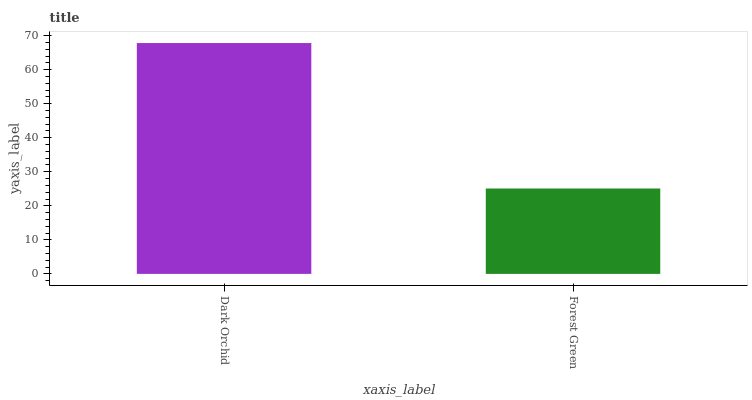Is Forest Green the minimum?
Answer yes or no. Yes. Is Dark Orchid the maximum?
Answer yes or no. Yes. Is Forest Green the maximum?
Answer yes or no. No. Is Dark Orchid greater than Forest Green?
Answer yes or no. Yes. Is Forest Green less than Dark Orchid?
Answer yes or no. Yes. Is Forest Green greater than Dark Orchid?
Answer yes or no. No. Is Dark Orchid less than Forest Green?
Answer yes or no. No. Is Dark Orchid the high median?
Answer yes or no. Yes. Is Forest Green the low median?
Answer yes or no. Yes. Is Forest Green the high median?
Answer yes or no. No. Is Dark Orchid the low median?
Answer yes or no. No. 